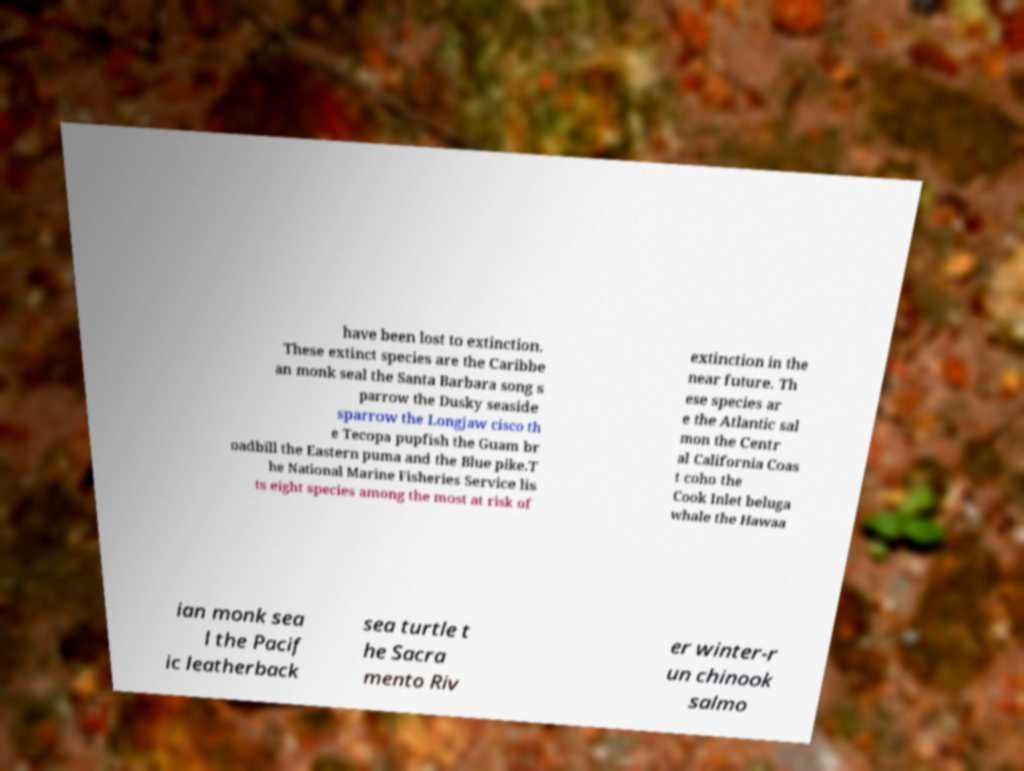Could you assist in decoding the text presented in this image and type it out clearly? have been lost to extinction. These extinct species are the Caribbe an monk seal the Santa Barbara song s parrow the Dusky seaside sparrow the Longjaw cisco th e Tecopa pupfish the Guam br oadbill the Eastern puma and the Blue pike.T he National Marine Fisheries Service lis ts eight species among the most at risk of extinction in the near future. Th ese species ar e the Atlantic sal mon the Centr al California Coas t coho the Cook Inlet beluga whale the Hawaa ian monk sea l the Pacif ic leatherback sea turtle t he Sacra mento Riv er winter-r un chinook salmo 